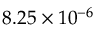Convert formula to latex. <formula><loc_0><loc_0><loc_500><loc_500>8 . 2 5 \times 1 0 ^ { - 6 }</formula> 